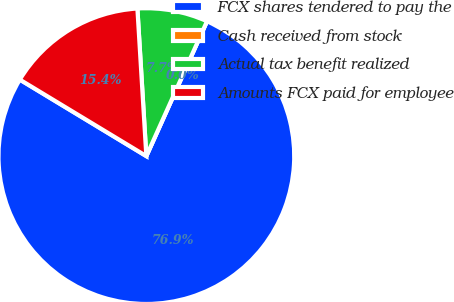Convert chart to OTSL. <chart><loc_0><loc_0><loc_500><loc_500><pie_chart><fcel>FCX shares tendered to pay the<fcel>Cash received from stock<fcel>Actual tax benefit realized<fcel>Amounts FCX paid for employee<nl><fcel>76.92%<fcel>0.0%<fcel>7.69%<fcel>15.38%<nl></chart> 